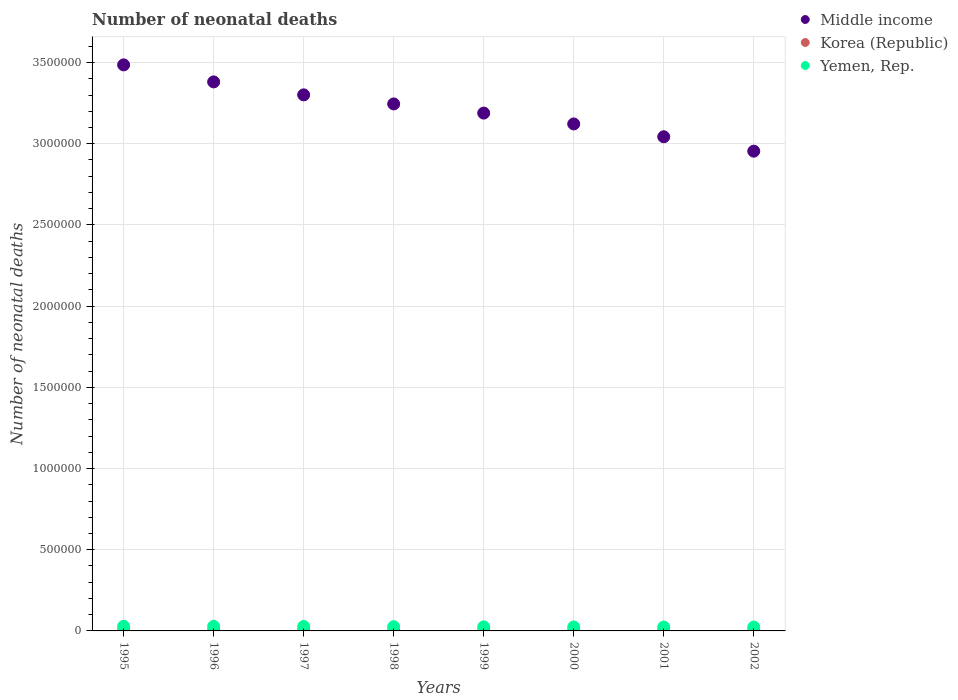How many different coloured dotlines are there?
Keep it short and to the point. 3. Is the number of dotlines equal to the number of legend labels?
Give a very brief answer. Yes. What is the number of neonatal deaths in in Korea (Republic) in 2001?
Your response must be concise. 1320. Across all years, what is the maximum number of neonatal deaths in in Korea (Republic)?
Provide a short and direct response. 1517. Across all years, what is the minimum number of neonatal deaths in in Korea (Republic)?
Your answer should be compact. 1191. In which year was the number of neonatal deaths in in Yemen, Rep. minimum?
Your response must be concise. 2002. What is the total number of neonatal deaths in in Yemen, Rep. in the graph?
Your answer should be very brief. 2.07e+05. What is the difference between the number of neonatal deaths in in Korea (Republic) in 2001 and that in 2002?
Your response must be concise. -79. What is the difference between the number of neonatal deaths in in Yemen, Rep. in 1995 and the number of neonatal deaths in in Middle income in 1996?
Your answer should be compact. -3.35e+06. What is the average number of neonatal deaths in in Yemen, Rep. per year?
Give a very brief answer. 2.59e+04. In the year 1999, what is the difference between the number of neonatal deaths in in Yemen, Rep. and number of neonatal deaths in in Korea (Republic)?
Your answer should be compact. 2.38e+04. In how many years, is the number of neonatal deaths in in Middle income greater than 1400000?
Offer a terse response. 8. What is the ratio of the number of neonatal deaths in in Yemen, Rep. in 1999 to that in 2001?
Your answer should be very brief. 1.05. What is the difference between the highest and the second highest number of neonatal deaths in in Yemen, Rep.?
Give a very brief answer. 426. What is the difference between the highest and the lowest number of neonatal deaths in in Korea (Republic)?
Offer a very short reply. 326. Is the number of neonatal deaths in in Middle income strictly greater than the number of neonatal deaths in in Yemen, Rep. over the years?
Make the answer very short. Yes. Are the values on the major ticks of Y-axis written in scientific E-notation?
Provide a short and direct response. No. Does the graph contain grids?
Offer a terse response. Yes. Where does the legend appear in the graph?
Ensure brevity in your answer.  Top right. How many legend labels are there?
Ensure brevity in your answer.  3. How are the legend labels stacked?
Make the answer very short. Vertical. What is the title of the graph?
Ensure brevity in your answer.  Number of neonatal deaths. Does "New Caledonia" appear as one of the legend labels in the graph?
Your answer should be compact. No. What is the label or title of the Y-axis?
Give a very brief answer. Number of neonatal deaths. What is the Number of neonatal deaths of Middle income in 1995?
Keep it short and to the point. 3.49e+06. What is the Number of neonatal deaths of Korea (Republic) in 1995?
Give a very brief answer. 1517. What is the Number of neonatal deaths in Yemen, Rep. in 1995?
Ensure brevity in your answer.  2.86e+04. What is the Number of neonatal deaths of Middle income in 1996?
Ensure brevity in your answer.  3.38e+06. What is the Number of neonatal deaths in Korea (Republic) in 1996?
Your response must be concise. 1392. What is the Number of neonatal deaths of Yemen, Rep. in 1996?
Make the answer very short. 2.82e+04. What is the Number of neonatal deaths of Middle income in 1997?
Ensure brevity in your answer.  3.30e+06. What is the Number of neonatal deaths in Korea (Republic) in 1997?
Give a very brief answer. 1288. What is the Number of neonatal deaths in Yemen, Rep. in 1997?
Offer a very short reply. 2.73e+04. What is the Number of neonatal deaths of Middle income in 1998?
Ensure brevity in your answer.  3.25e+06. What is the Number of neonatal deaths of Korea (Republic) in 1998?
Offer a very short reply. 1215. What is the Number of neonatal deaths in Yemen, Rep. in 1998?
Your answer should be very brief. 2.60e+04. What is the Number of neonatal deaths of Middle income in 1999?
Offer a very short reply. 3.19e+06. What is the Number of neonatal deaths in Korea (Republic) in 1999?
Ensure brevity in your answer.  1191. What is the Number of neonatal deaths of Yemen, Rep. in 1999?
Give a very brief answer. 2.50e+04. What is the Number of neonatal deaths of Middle income in 2000?
Provide a succinct answer. 3.12e+06. What is the Number of neonatal deaths of Korea (Republic) in 2000?
Your answer should be compact. 1235. What is the Number of neonatal deaths of Yemen, Rep. in 2000?
Offer a terse response. 2.42e+04. What is the Number of neonatal deaths in Middle income in 2001?
Keep it short and to the point. 3.04e+06. What is the Number of neonatal deaths of Korea (Republic) in 2001?
Ensure brevity in your answer.  1320. What is the Number of neonatal deaths of Yemen, Rep. in 2001?
Keep it short and to the point. 2.38e+04. What is the Number of neonatal deaths of Middle income in 2002?
Your answer should be compact. 2.95e+06. What is the Number of neonatal deaths of Korea (Republic) in 2002?
Your answer should be very brief. 1399. What is the Number of neonatal deaths of Yemen, Rep. in 2002?
Offer a terse response. 2.38e+04. Across all years, what is the maximum Number of neonatal deaths in Middle income?
Offer a terse response. 3.49e+06. Across all years, what is the maximum Number of neonatal deaths of Korea (Republic)?
Provide a succinct answer. 1517. Across all years, what is the maximum Number of neonatal deaths in Yemen, Rep.?
Your response must be concise. 2.86e+04. Across all years, what is the minimum Number of neonatal deaths of Middle income?
Give a very brief answer. 2.95e+06. Across all years, what is the minimum Number of neonatal deaths in Korea (Republic)?
Your response must be concise. 1191. Across all years, what is the minimum Number of neonatal deaths in Yemen, Rep.?
Ensure brevity in your answer.  2.38e+04. What is the total Number of neonatal deaths of Middle income in the graph?
Ensure brevity in your answer.  2.57e+07. What is the total Number of neonatal deaths of Korea (Republic) in the graph?
Your response must be concise. 1.06e+04. What is the total Number of neonatal deaths of Yemen, Rep. in the graph?
Make the answer very short. 2.07e+05. What is the difference between the Number of neonatal deaths of Middle income in 1995 and that in 1996?
Your answer should be compact. 1.05e+05. What is the difference between the Number of neonatal deaths in Korea (Republic) in 1995 and that in 1996?
Ensure brevity in your answer.  125. What is the difference between the Number of neonatal deaths of Yemen, Rep. in 1995 and that in 1996?
Provide a short and direct response. 426. What is the difference between the Number of neonatal deaths in Middle income in 1995 and that in 1997?
Keep it short and to the point. 1.85e+05. What is the difference between the Number of neonatal deaths of Korea (Republic) in 1995 and that in 1997?
Your response must be concise. 229. What is the difference between the Number of neonatal deaths of Yemen, Rep. in 1995 and that in 1997?
Give a very brief answer. 1349. What is the difference between the Number of neonatal deaths in Middle income in 1995 and that in 1998?
Provide a succinct answer. 2.40e+05. What is the difference between the Number of neonatal deaths in Korea (Republic) in 1995 and that in 1998?
Provide a short and direct response. 302. What is the difference between the Number of neonatal deaths of Yemen, Rep. in 1995 and that in 1998?
Make the answer very short. 2568. What is the difference between the Number of neonatal deaths in Middle income in 1995 and that in 1999?
Ensure brevity in your answer.  2.97e+05. What is the difference between the Number of neonatal deaths of Korea (Republic) in 1995 and that in 1999?
Provide a short and direct response. 326. What is the difference between the Number of neonatal deaths in Yemen, Rep. in 1995 and that in 1999?
Offer a very short reply. 3661. What is the difference between the Number of neonatal deaths in Middle income in 1995 and that in 2000?
Make the answer very short. 3.64e+05. What is the difference between the Number of neonatal deaths of Korea (Republic) in 1995 and that in 2000?
Offer a terse response. 282. What is the difference between the Number of neonatal deaths in Yemen, Rep. in 1995 and that in 2000?
Your response must be concise. 4464. What is the difference between the Number of neonatal deaths of Middle income in 1995 and that in 2001?
Provide a succinct answer. 4.43e+05. What is the difference between the Number of neonatal deaths of Korea (Republic) in 1995 and that in 2001?
Ensure brevity in your answer.  197. What is the difference between the Number of neonatal deaths of Yemen, Rep. in 1995 and that in 2001?
Provide a short and direct response. 4795. What is the difference between the Number of neonatal deaths in Middle income in 1995 and that in 2002?
Provide a succinct answer. 5.31e+05. What is the difference between the Number of neonatal deaths of Korea (Republic) in 1995 and that in 2002?
Your answer should be compact. 118. What is the difference between the Number of neonatal deaths of Yemen, Rep. in 1995 and that in 2002?
Keep it short and to the point. 4806. What is the difference between the Number of neonatal deaths in Middle income in 1996 and that in 1997?
Offer a very short reply. 7.98e+04. What is the difference between the Number of neonatal deaths of Korea (Republic) in 1996 and that in 1997?
Your response must be concise. 104. What is the difference between the Number of neonatal deaths in Yemen, Rep. in 1996 and that in 1997?
Offer a very short reply. 923. What is the difference between the Number of neonatal deaths of Middle income in 1996 and that in 1998?
Offer a terse response. 1.36e+05. What is the difference between the Number of neonatal deaths in Korea (Republic) in 1996 and that in 1998?
Offer a very short reply. 177. What is the difference between the Number of neonatal deaths in Yemen, Rep. in 1996 and that in 1998?
Offer a very short reply. 2142. What is the difference between the Number of neonatal deaths in Middle income in 1996 and that in 1999?
Your answer should be compact. 1.92e+05. What is the difference between the Number of neonatal deaths in Korea (Republic) in 1996 and that in 1999?
Your response must be concise. 201. What is the difference between the Number of neonatal deaths in Yemen, Rep. in 1996 and that in 1999?
Your answer should be very brief. 3235. What is the difference between the Number of neonatal deaths in Middle income in 1996 and that in 2000?
Ensure brevity in your answer.  2.59e+05. What is the difference between the Number of neonatal deaths in Korea (Republic) in 1996 and that in 2000?
Keep it short and to the point. 157. What is the difference between the Number of neonatal deaths in Yemen, Rep. in 1996 and that in 2000?
Offer a very short reply. 4038. What is the difference between the Number of neonatal deaths of Middle income in 1996 and that in 2001?
Provide a short and direct response. 3.38e+05. What is the difference between the Number of neonatal deaths in Korea (Republic) in 1996 and that in 2001?
Your answer should be very brief. 72. What is the difference between the Number of neonatal deaths in Yemen, Rep. in 1996 and that in 2001?
Ensure brevity in your answer.  4369. What is the difference between the Number of neonatal deaths in Middle income in 1996 and that in 2002?
Give a very brief answer. 4.27e+05. What is the difference between the Number of neonatal deaths of Korea (Republic) in 1996 and that in 2002?
Make the answer very short. -7. What is the difference between the Number of neonatal deaths of Yemen, Rep. in 1996 and that in 2002?
Provide a short and direct response. 4380. What is the difference between the Number of neonatal deaths in Middle income in 1997 and that in 1998?
Offer a terse response. 5.58e+04. What is the difference between the Number of neonatal deaths of Yemen, Rep. in 1997 and that in 1998?
Make the answer very short. 1219. What is the difference between the Number of neonatal deaths in Middle income in 1997 and that in 1999?
Your response must be concise. 1.12e+05. What is the difference between the Number of neonatal deaths in Korea (Republic) in 1997 and that in 1999?
Offer a very short reply. 97. What is the difference between the Number of neonatal deaths in Yemen, Rep. in 1997 and that in 1999?
Ensure brevity in your answer.  2312. What is the difference between the Number of neonatal deaths of Middle income in 1997 and that in 2000?
Your response must be concise. 1.79e+05. What is the difference between the Number of neonatal deaths in Yemen, Rep. in 1997 and that in 2000?
Offer a terse response. 3115. What is the difference between the Number of neonatal deaths of Middle income in 1997 and that in 2001?
Your answer should be very brief. 2.58e+05. What is the difference between the Number of neonatal deaths of Korea (Republic) in 1997 and that in 2001?
Your response must be concise. -32. What is the difference between the Number of neonatal deaths of Yemen, Rep. in 1997 and that in 2001?
Offer a terse response. 3446. What is the difference between the Number of neonatal deaths of Middle income in 1997 and that in 2002?
Keep it short and to the point. 3.47e+05. What is the difference between the Number of neonatal deaths of Korea (Republic) in 1997 and that in 2002?
Offer a very short reply. -111. What is the difference between the Number of neonatal deaths of Yemen, Rep. in 1997 and that in 2002?
Your answer should be compact. 3457. What is the difference between the Number of neonatal deaths of Middle income in 1998 and that in 1999?
Provide a short and direct response. 5.65e+04. What is the difference between the Number of neonatal deaths of Yemen, Rep. in 1998 and that in 1999?
Provide a succinct answer. 1093. What is the difference between the Number of neonatal deaths in Middle income in 1998 and that in 2000?
Your answer should be compact. 1.23e+05. What is the difference between the Number of neonatal deaths in Korea (Republic) in 1998 and that in 2000?
Give a very brief answer. -20. What is the difference between the Number of neonatal deaths in Yemen, Rep. in 1998 and that in 2000?
Keep it short and to the point. 1896. What is the difference between the Number of neonatal deaths in Middle income in 1998 and that in 2001?
Your response must be concise. 2.02e+05. What is the difference between the Number of neonatal deaths of Korea (Republic) in 1998 and that in 2001?
Make the answer very short. -105. What is the difference between the Number of neonatal deaths of Yemen, Rep. in 1998 and that in 2001?
Provide a short and direct response. 2227. What is the difference between the Number of neonatal deaths of Middle income in 1998 and that in 2002?
Ensure brevity in your answer.  2.91e+05. What is the difference between the Number of neonatal deaths in Korea (Republic) in 1998 and that in 2002?
Make the answer very short. -184. What is the difference between the Number of neonatal deaths in Yemen, Rep. in 1998 and that in 2002?
Give a very brief answer. 2238. What is the difference between the Number of neonatal deaths in Middle income in 1999 and that in 2000?
Your answer should be very brief. 6.68e+04. What is the difference between the Number of neonatal deaths in Korea (Republic) in 1999 and that in 2000?
Your answer should be compact. -44. What is the difference between the Number of neonatal deaths of Yemen, Rep. in 1999 and that in 2000?
Ensure brevity in your answer.  803. What is the difference between the Number of neonatal deaths in Middle income in 1999 and that in 2001?
Provide a succinct answer. 1.46e+05. What is the difference between the Number of neonatal deaths in Korea (Republic) in 1999 and that in 2001?
Your answer should be compact. -129. What is the difference between the Number of neonatal deaths of Yemen, Rep. in 1999 and that in 2001?
Keep it short and to the point. 1134. What is the difference between the Number of neonatal deaths of Middle income in 1999 and that in 2002?
Offer a very short reply. 2.35e+05. What is the difference between the Number of neonatal deaths of Korea (Republic) in 1999 and that in 2002?
Ensure brevity in your answer.  -208. What is the difference between the Number of neonatal deaths in Yemen, Rep. in 1999 and that in 2002?
Provide a short and direct response. 1145. What is the difference between the Number of neonatal deaths of Middle income in 2000 and that in 2001?
Your response must be concise. 7.89e+04. What is the difference between the Number of neonatal deaths of Korea (Republic) in 2000 and that in 2001?
Provide a succinct answer. -85. What is the difference between the Number of neonatal deaths of Yemen, Rep. in 2000 and that in 2001?
Your answer should be compact. 331. What is the difference between the Number of neonatal deaths in Middle income in 2000 and that in 2002?
Your answer should be very brief. 1.68e+05. What is the difference between the Number of neonatal deaths of Korea (Republic) in 2000 and that in 2002?
Your response must be concise. -164. What is the difference between the Number of neonatal deaths of Yemen, Rep. in 2000 and that in 2002?
Your answer should be very brief. 342. What is the difference between the Number of neonatal deaths in Middle income in 2001 and that in 2002?
Make the answer very short. 8.88e+04. What is the difference between the Number of neonatal deaths of Korea (Republic) in 2001 and that in 2002?
Give a very brief answer. -79. What is the difference between the Number of neonatal deaths of Yemen, Rep. in 2001 and that in 2002?
Make the answer very short. 11. What is the difference between the Number of neonatal deaths in Middle income in 1995 and the Number of neonatal deaths in Korea (Republic) in 1996?
Offer a very short reply. 3.48e+06. What is the difference between the Number of neonatal deaths of Middle income in 1995 and the Number of neonatal deaths of Yemen, Rep. in 1996?
Offer a terse response. 3.46e+06. What is the difference between the Number of neonatal deaths in Korea (Republic) in 1995 and the Number of neonatal deaths in Yemen, Rep. in 1996?
Your answer should be very brief. -2.67e+04. What is the difference between the Number of neonatal deaths of Middle income in 1995 and the Number of neonatal deaths of Korea (Republic) in 1997?
Make the answer very short. 3.48e+06. What is the difference between the Number of neonatal deaths of Middle income in 1995 and the Number of neonatal deaths of Yemen, Rep. in 1997?
Make the answer very short. 3.46e+06. What is the difference between the Number of neonatal deaths in Korea (Republic) in 1995 and the Number of neonatal deaths in Yemen, Rep. in 1997?
Provide a succinct answer. -2.58e+04. What is the difference between the Number of neonatal deaths of Middle income in 1995 and the Number of neonatal deaths of Korea (Republic) in 1998?
Give a very brief answer. 3.48e+06. What is the difference between the Number of neonatal deaths of Middle income in 1995 and the Number of neonatal deaths of Yemen, Rep. in 1998?
Make the answer very short. 3.46e+06. What is the difference between the Number of neonatal deaths in Korea (Republic) in 1995 and the Number of neonatal deaths in Yemen, Rep. in 1998?
Your answer should be very brief. -2.45e+04. What is the difference between the Number of neonatal deaths of Middle income in 1995 and the Number of neonatal deaths of Korea (Republic) in 1999?
Your response must be concise. 3.48e+06. What is the difference between the Number of neonatal deaths of Middle income in 1995 and the Number of neonatal deaths of Yemen, Rep. in 1999?
Your answer should be very brief. 3.46e+06. What is the difference between the Number of neonatal deaths in Korea (Republic) in 1995 and the Number of neonatal deaths in Yemen, Rep. in 1999?
Provide a short and direct response. -2.34e+04. What is the difference between the Number of neonatal deaths in Middle income in 1995 and the Number of neonatal deaths in Korea (Republic) in 2000?
Ensure brevity in your answer.  3.48e+06. What is the difference between the Number of neonatal deaths in Middle income in 1995 and the Number of neonatal deaths in Yemen, Rep. in 2000?
Your response must be concise. 3.46e+06. What is the difference between the Number of neonatal deaths of Korea (Republic) in 1995 and the Number of neonatal deaths of Yemen, Rep. in 2000?
Provide a succinct answer. -2.26e+04. What is the difference between the Number of neonatal deaths in Middle income in 1995 and the Number of neonatal deaths in Korea (Republic) in 2001?
Offer a very short reply. 3.48e+06. What is the difference between the Number of neonatal deaths of Middle income in 1995 and the Number of neonatal deaths of Yemen, Rep. in 2001?
Your answer should be compact. 3.46e+06. What is the difference between the Number of neonatal deaths in Korea (Republic) in 1995 and the Number of neonatal deaths in Yemen, Rep. in 2001?
Your answer should be compact. -2.23e+04. What is the difference between the Number of neonatal deaths of Middle income in 1995 and the Number of neonatal deaths of Korea (Republic) in 2002?
Offer a terse response. 3.48e+06. What is the difference between the Number of neonatal deaths of Middle income in 1995 and the Number of neonatal deaths of Yemen, Rep. in 2002?
Your answer should be very brief. 3.46e+06. What is the difference between the Number of neonatal deaths of Korea (Republic) in 1995 and the Number of neonatal deaths of Yemen, Rep. in 2002?
Your response must be concise. -2.23e+04. What is the difference between the Number of neonatal deaths of Middle income in 1996 and the Number of neonatal deaths of Korea (Republic) in 1997?
Ensure brevity in your answer.  3.38e+06. What is the difference between the Number of neonatal deaths in Middle income in 1996 and the Number of neonatal deaths in Yemen, Rep. in 1997?
Ensure brevity in your answer.  3.35e+06. What is the difference between the Number of neonatal deaths in Korea (Republic) in 1996 and the Number of neonatal deaths in Yemen, Rep. in 1997?
Your response must be concise. -2.59e+04. What is the difference between the Number of neonatal deaths in Middle income in 1996 and the Number of neonatal deaths in Korea (Republic) in 1998?
Your answer should be very brief. 3.38e+06. What is the difference between the Number of neonatal deaths in Middle income in 1996 and the Number of neonatal deaths in Yemen, Rep. in 1998?
Provide a short and direct response. 3.35e+06. What is the difference between the Number of neonatal deaths of Korea (Republic) in 1996 and the Number of neonatal deaths of Yemen, Rep. in 1998?
Your answer should be very brief. -2.47e+04. What is the difference between the Number of neonatal deaths in Middle income in 1996 and the Number of neonatal deaths in Korea (Republic) in 1999?
Your answer should be very brief. 3.38e+06. What is the difference between the Number of neonatal deaths of Middle income in 1996 and the Number of neonatal deaths of Yemen, Rep. in 1999?
Offer a terse response. 3.36e+06. What is the difference between the Number of neonatal deaths of Korea (Republic) in 1996 and the Number of neonatal deaths of Yemen, Rep. in 1999?
Your answer should be compact. -2.36e+04. What is the difference between the Number of neonatal deaths in Middle income in 1996 and the Number of neonatal deaths in Korea (Republic) in 2000?
Ensure brevity in your answer.  3.38e+06. What is the difference between the Number of neonatal deaths in Middle income in 1996 and the Number of neonatal deaths in Yemen, Rep. in 2000?
Provide a succinct answer. 3.36e+06. What is the difference between the Number of neonatal deaths in Korea (Republic) in 1996 and the Number of neonatal deaths in Yemen, Rep. in 2000?
Your answer should be very brief. -2.28e+04. What is the difference between the Number of neonatal deaths of Middle income in 1996 and the Number of neonatal deaths of Korea (Republic) in 2001?
Keep it short and to the point. 3.38e+06. What is the difference between the Number of neonatal deaths of Middle income in 1996 and the Number of neonatal deaths of Yemen, Rep. in 2001?
Offer a terse response. 3.36e+06. What is the difference between the Number of neonatal deaths of Korea (Republic) in 1996 and the Number of neonatal deaths of Yemen, Rep. in 2001?
Your response must be concise. -2.24e+04. What is the difference between the Number of neonatal deaths in Middle income in 1996 and the Number of neonatal deaths in Korea (Republic) in 2002?
Make the answer very short. 3.38e+06. What is the difference between the Number of neonatal deaths in Middle income in 1996 and the Number of neonatal deaths in Yemen, Rep. in 2002?
Make the answer very short. 3.36e+06. What is the difference between the Number of neonatal deaths in Korea (Republic) in 1996 and the Number of neonatal deaths in Yemen, Rep. in 2002?
Give a very brief answer. -2.24e+04. What is the difference between the Number of neonatal deaths of Middle income in 1997 and the Number of neonatal deaths of Korea (Republic) in 1998?
Ensure brevity in your answer.  3.30e+06. What is the difference between the Number of neonatal deaths in Middle income in 1997 and the Number of neonatal deaths in Yemen, Rep. in 1998?
Provide a succinct answer. 3.27e+06. What is the difference between the Number of neonatal deaths of Korea (Republic) in 1997 and the Number of neonatal deaths of Yemen, Rep. in 1998?
Offer a terse response. -2.48e+04. What is the difference between the Number of neonatal deaths of Middle income in 1997 and the Number of neonatal deaths of Korea (Republic) in 1999?
Offer a very short reply. 3.30e+06. What is the difference between the Number of neonatal deaths of Middle income in 1997 and the Number of neonatal deaths of Yemen, Rep. in 1999?
Offer a very short reply. 3.28e+06. What is the difference between the Number of neonatal deaths of Korea (Republic) in 1997 and the Number of neonatal deaths of Yemen, Rep. in 1999?
Offer a very short reply. -2.37e+04. What is the difference between the Number of neonatal deaths of Middle income in 1997 and the Number of neonatal deaths of Korea (Republic) in 2000?
Offer a very short reply. 3.30e+06. What is the difference between the Number of neonatal deaths in Middle income in 1997 and the Number of neonatal deaths in Yemen, Rep. in 2000?
Make the answer very short. 3.28e+06. What is the difference between the Number of neonatal deaths of Korea (Republic) in 1997 and the Number of neonatal deaths of Yemen, Rep. in 2000?
Provide a succinct answer. -2.29e+04. What is the difference between the Number of neonatal deaths in Middle income in 1997 and the Number of neonatal deaths in Korea (Republic) in 2001?
Your answer should be very brief. 3.30e+06. What is the difference between the Number of neonatal deaths of Middle income in 1997 and the Number of neonatal deaths of Yemen, Rep. in 2001?
Keep it short and to the point. 3.28e+06. What is the difference between the Number of neonatal deaths of Korea (Republic) in 1997 and the Number of neonatal deaths of Yemen, Rep. in 2001?
Offer a terse response. -2.25e+04. What is the difference between the Number of neonatal deaths in Middle income in 1997 and the Number of neonatal deaths in Korea (Republic) in 2002?
Your answer should be very brief. 3.30e+06. What is the difference between the Number of neonatal deaths in Middle income in 1997 and the Number of neonatal deaths in Yemen, Rep. in 2002?
Give a very brief answer. 3.28e+06. What is the difference between the Number of neonatal deaths in Korea (Republic) in 1997 and the Number of neonatal deaths in Yemen, Rep. in 2002?
Provide a short and direct response. -2.25e+04. What is the difference between the Number of neonatal deaths in Middle income in 1998 and the Number of neonatal deaths in Korea (Republic) in 1999?
Provide a short and direct response. 3.24e+06. What is the difference between the Number of neonatal deaths in Middle income in 1998 and the Number of neonatal deaths in Yemen, Rep. in 1999?
Offer a terse response. 3.22e+06. What is the difference between the Number of neonatal deaths of Korea (Republic) in 1998 and the Number of neonatal deaths of Yemen, Rep. in 1999?
Your response must be concise. -2.37e+04. What is the difference between the Number of neonatal deaths of Middle income in 1998 and the Number of neonatal deaths of Korea (Republic) in 2000?
Offer a terse response. 3.24e+06. What is the difference between the Number of neonatal deaths in Middle income in 1998 and the Number of neonatal deaths in Yemen, Rep. in 2000?
Keep it short and to the point. 3.22e+06. What is the difference between the Number of neonatal deaths of Korea (Republic) in 1998 and the Number of neonatal deaths of Yemen, Rep. in 2000?
Give a very brief answer. -2.29e+04. What is the difference between the Number of neonatal deaths of Middle income in 1998 and the Number of neonatal deaths of Korea (Republic) in 2001?
Your answer should be compact. 3.24e+06. What is the difference between the Number of neonatal deaths of Middle income in 1998 and the Number of neonatal deaths of Yemen, Rep. in 2001?
Offer a terse response. 3.22e+06. What is the difference between the Number of neonatal deaths of Korea (Republic) in 1998 and the Number of neonatal deaths of Yemen, Rep. in 2001?
Your response must be concise. -2.26e+04. What is the difference between the Number of neonatal deaths in Middle income in 1998 and the Number of neonatal deaths in Korea (Republic) in 2002?
Your answer should be very brief. 3.24e+06. What is the difference between the Number of neonatal deaths of Middle income in 1998 and the Number of neonatal deaths of Yemen, Rep. in 2002?
Offer a terse response. 3.22e+06. What is the difference between the Number of neonatal deaths in Korea (Republic) in 1998 and the Number of neonatal deaths in Yemen, Rep. in 2002?
Make the answer very short. -2.26e+04. What is the difference between the Number of neonatal deaths in Middle income in 1999 and the Number of neonatal deaths in Korea (Republic) in 2000?
Ensure brevity in your answer.  3.19e+06. What is the difference between the Number of neonatal deaths of Middle income in 1999 and the Number of neonatal deaths of Yemen, Rep. in 2000?
Your answer should be compact. 3.16e+06. What is the difference between the Number of neonatal deaths in Korea (Republic) in 1999 and the Number of neonatal deaths in Yemen, Rep. in 2000?
Your answer should be compact. -2.30e+04. What is the difference between the Number of neonatal deaths in Middle income in 1999 and the Number of neonatal deaths in Korea (Republic) in 2001?
Keep it short and to the point. 3.19e+06. What is the difference between the Number of neonatal deaths of Middle income in 1999 and the Number of neonatal deaths of Yemen, Rep. in 2001?
Your answer should be very brief. 3.16e+06. What is the difference between the Number of neonatal deaths of Korea (Republic) in 1999 and the Number of neonatal deaths of Yemen, Rep. in 2001?
Offer a very short reply. -2.26e+04. What is the difference between the Number of neonatal deaths of Middle income in 1999 and the Number of neonatal deaths of Korea (Republic) in 2002?
Your response must be concise. 3.19e+06. What is the difference between the Number of neonatal deaths of Middle income in 1999 and the Number of neonatal deaths of Yemen, Rep. in 2002?
Offer a terse response. 3.16e+06. What is the difference between the Number of neonatal deaths of Korea (Republic) in 1999 and the Number of neonatal deaths of Yemen, Rep. in 2002?
Offer a very short reply. -2.26e+04. What is the difference between the Number of neonatal deaths in Middle income in 2000 and the Number of neonatal deaths in Korea (Republic) in 2001?
Ensure brevity in your answer.  3.12e+06. What is the difference between the Number of neonatal deaths of Middle income in 2000 and the Number of neonatal deaths of Yemen, Rep. in 2001?
Ensure brevity in your answer.  3.10e+06. What is the difference between the Number of neonatal deaths of Korea (Republic) in 2000 and the Number of neonatal deaths of Yemen, Rep. in 2001?
Keep it short and to the point. -2.26e+04. What is the difference between the Number of neonatal deaths in Middle income in 2000 and the Number of neonatal deaths in Korea (Republic) in 2002?
Offer a terse response. 3.12e+06. What is the difference between the Number of neonatal deaths in Middle income in 2000 and the Number of neonatal deaths in Yemen, Rep. in 2002?
Ensure brevity in your answer.  3.10e+06. What is the difference between the Number of neonatal deaths in Korea (Republic) in 2000 and the Number of neonatal deaths in Yemen, Rep. in 2002?
Offer a very short reply. -2.26e+04. What is the difference between the Number of neonatal deaths of Middle income in 2001 and the Number of neonatal deaths of Korea (Republic) in 2002?
Your answer should be compact. 3.04e+06. What is the difference between the Number of neonatal deaths in Middle income in 2001 and the Number of neonatal deaths in Yemen, Rep. in 2002?
Offer a very short reply. 3.02e+06. What is the difference between the Number of neonatal deaths in Korea (Republic) in 2001 and the Number of neonatal deaths in Yemen, Rep. in 2002?
Provide a short and direct response. -2.25e+04. What is the average Number of neonatal deaths in Middle income per year?
Your answer should be very brief. 3.22e+06. What is the average Number of neonatal deaths of Korea (Republic) per year?
Offer a very short reply. 1319.62. What is the average Number of neonatal deaths in Yemen, Rep. per year?
Provide a short and direct response. 2.59e+04. In the year 1995, what is the difference between the Number of neonatal deaths of Middle income and Number of neonatal deaths of Korea (Republic)?
Offer a very short reply. 3.48e+06. In the year 1995, what is the difference between the Number of neonatal deaths of Middle income and Number of neonatal deaths of Yemen, Rep.?
Your response must be concise. 3.46e+06. In the year 1995, what is the difference between the Number of neonatal deaths of Korea (Republic) and Number of neonatal deaths of Yemen, Rep.?
Give a very brief answer. -2.71e+04. In the year 1996, what is the difference between the Number of neonatal deaths of Middle income and Number of neonatal deaths of Korea (Republic)?
Your response must be concise. 3.38e+06. In the year 1996, what is the difference between the Number of neonatal deaths of Middle income and Number of neonatal deaths of Yemen, Rep.?
Your response must be concise. 3.35e+06. In the year 1996, what is the difference between the Number of neonatal deaths of Korea (Republic) and Number of neonatal deaths of Yemen, Rep.?
Give a very brief answer. -2.68e+04. In the year 1997, what is the difference between the Number of neonatal deaths in Middle income and Number of neonatal deaths in Korea (Republic)?
Provide a short and direct response. 3.30e+06. In the year 1997, what is the difference between the Number of neonatal deaths of Middle income and Number of neonatal deaths of Yemen, Rep.?
Your answer should be very brief. 3.27e+06. In the year 1997, what is the difference between the Number of neonatal deaths in Korea (Republic) and Number of neonatal deaths in Yemen, Rep.?
Your answer should be compact. -2.60e+04. In the year 1998, what is the difference between the Number of neonatal deaths of Middle income and Number of neonatal deaths of Korea (Republic)?
Offer a very short reply. 3.24e+06. In the year 1998, what is the difference between the Number of neonatal deaths in Middle income and Number of neonatal deaths in Yemen, Rep.?
Ensure brevity in your answer.  3.22e+06. In the year 1998, what is the difference between the Number of neonatal deaths of Korea (Republic) and Number of neonatal deaths of Yemen, Rep.?
Provide a succinct answer. -2.48e+04. In the year 1999, what is the difference between the Number of neonatal deaths in Middle income and Number of neonatal deaths in Korea (Republic)?
Your response must be concise. 3.19e+06. In the year 1999, what is the difference between the Number of neonatal deaths of Middle income and Number of neonatal deaths of Yemen, Rep.?
Make the answer very short. 3.16e+06. In the year 1999, what is the difference between the Number of neonatal deaths of Korea (Republic) and Number of neonatal deaths of Yemen, Rep.?
Your answer should be compact. -2.38e+04. In the year 2000, what is the difference between the Number of neonatal deaths in Middle income and Number of neonatal deaths in Korea (Republic)?
Your answer should be very brief. 3.12e+06. In the year 2000, what is the difference between the Number of neonatal deaths of Middle income and Number of neonatal deaths of Yemen, Rep.?
Your answer should be very brief. 3.10e+06. In the year 2000, what is the difference between the Number of neonatal deaths in Korea (Republic) and Number of neonatal deaths in Yemen, Rep.?
Your answer should be very brief. -2.29e+04. In the year 2001, what is the difference between the Number of neonatal deaths in Middle income and Number of neonatal deaths in Korea (Republic)?
Your answer should be compact. 3.04e+06. In the year 2001, what is the difference between the Number of neonatal deaths in Middle income and Number of neonatal deaths in Yemen, Rep.?
Make the answer very short. 3.02e+06. In the year 2001, what is the difference between the Number of neonatal deaths in Korea (Republic) and Number of neonatal deaths in Yemen, Rep.?
Make the answer very short. -2.25e+04. In the year 2002, what is the difference between the Number of neonatal deaths in Middle income and Number of neonatal deaths in Korea (Republic)?
Keep it short and to the point. 2.95e+06. In the year 2002, what is the difference between the Number of neonatal deaths of Middle income and Number of neonatal deaths of Yemen, Rep.?
Your answer should be very brief. 2.93e+06. In the year 2002, what is the difference between the Number of neonatal deaths in Korea (Republic) and Number of neonatal deaths in Yemen, Rep.?
Provide a succinct answer. -2.24e+04. What is the ratio of the Number of neonatal deaths in Middle income in 1995 to that in 1996?
Your answer should be compact. 1.03. What is the ratio of the Number of neonatal deaths in Korea (Republic) in 1995 to that in 1996?
Offer a terse response. 1.09. What is the ratio of the Number of neonatal deaths in Yemen, Rep. in 1995 to that in 1996?
Your answer should be compact. 1.02. What is the ratio of the Number of neonatal deaths in Middle income in 1995 to that in 1997?
Ensure brevity in your answer.  1.06. What is the ratio of the Number of neonatal deaths in Korea (Republic) in 1995 to that in 1997?
Give a very brief answer. 1.18. What is the ratio of the Number of neonatal deaths in Yemen, Rep. in 1995 to that in 1997?
Ensure brevity in your answer.  1.05. What is the ratio of the Number of neonatal deaths of Middle income in 1995 to that in 1998?
Provide a succinct answer. 1.07. What is the ratio of the Number of neonatal deaths of Korea (Republic) in 1995 to that in 1998?
Ensure brevity in your answer.  1.25. What is the ratio of the Number of neonatal deaths in Yemen, Rep. in 1995 to that in 1998?
Provide a succinct answer. 1.1. What is the ratio of the Number of neonatal deaths in Middle income in 1995 to that in 1999?
Your answer should be very brief. 1.09. What is the ratio of the Number of neonatal deaths in Korea (Republic) in 1995 to that in 1999?
Your response must be concise. 1.27. What is the ratio of the Number of neonatal deaths of Yemen, Rep. in 1995 to that in 1999?
Offer a terse response. 1.15. What is the ratio of the Number of neonatal deaths of Middle income in 1995 to that in 2000?
Keep it short and to the point. 1.12. What is the ratio of the Number of neonatal deaths in Korea (Republic) in 1995 to that in 2000?
Provide a succinct answer. 1.23. What is the ratio of the Number of neonatal deaths of Yemen, Rep. in 1995 to that in 2000?
Your answer should be very brief. 1.18. What is the ratio of the Number of neonatal deaths in Middle income in 1995 to that in 2001?
Make the answer very short. 1.15. What is the ratio of the Number of neonatal deaths of Korea (Republic) in 1995 to that in 2001?
Your response must be concise. 1.15. What is the ratio of the Number of neonatal deaths of Yemen, Rep. in 1995 to that in 2001?
Keep it short and to the point. 1.2. What is the ratio of the Number of neonatal deaths in Middle income in 1995 to that in 2002?
Provide a succinct answer. 1.18. What is the ratio of the Number of neonatal deaths of Korea (Republic) in 1995 to that in 2002?
Provide a succinct answer. 1.08. What is the ratio of the Number of neonatal deaths of Yemen, Rep. in 1995 to that in 2002?
Ensure brevity in your answer.  1.2. What is the ratio of the Number of neonatal deaths of Middle income in 1996 to that in 1997?
Keep it short and to the point. 1.02. What is the ratio of the Number of neonatal deaths in Korea (Republic) in 1996 to that in 1997?
Offer a terse response. 1.08. What is the ratio of the Number of neonatal deaths in Yemen, Rep. in 1996 to that in 1997?
Provide a succinct answer. 1.03. What is the ratio of the Number of neonatal deaths in Middle income in 1996 to that in 1998?
Offer a very short reply. 1.04. What is the ratio of the Number of neonatal deaths in Korea (Republic) in 1996 to that in 1998?
Make the answer very short. 1.15. What is the ratio of the Number of neonatal deaths of Yemen, Rep. in 1996 to that in 1998?
Keep it short and to the point. 1.08. What is the ratio of the Number of neonatal deaths in Middle income in 1996 to that in 1999?
Keep it short and to the point. 1.06. What is the ratio of the Number of neonatal deaths in Korea (Republic) in 1996 to that in 1999?
Provide a succinct answer. 1.17. What is the ratio of the Number of neonatal deaths of Yemen, Rep. in 1996 to that in 1999?
Your answer should be very brief. 1.13. What is the ratio of the Number of neonatal deaths of Middle income in 1996 to that in 2000?
Make the answer very short. 1.08. What is the ratio of the Number of neonatal deaths of Korea (Republic) in 1996 to that in 2000?
Make the answer very short. 1.13. What is the ratio of the Number of neonatal deaths in Yemen, Rep. in 1996 to that in 2000?
Offer a very short reply. 1.17. What is the ratio of the Number of neonatal deaths in Middle income in 1996 to that in 2001?
Provide a succinct answer. 1.11. What is the ratio of the Number of neonatal deaths of Korea (Republic) in 1996 to that in 2001?
Ensure brevity in your answer.  1.05. What is the ratio of the Number of neonatal deaths of Yemen, Rep. in 1996 to that in 2001?
Provide a succinct answer. 1.18. What is the ratio of the Number of neonatal deaths in Middle income in 1996 to that in 2002?
Give a very brief answer. 1.14. What is the ratio of the Number of neonatal deaths of Korea (Republic) in 1996 to that in 2002?
Your response must be concise. 0.99. What is the ratio of the Number of neonatal deaths of Yemen, Rep. in 1996 to that in 2002?
Your response must be concise. 1.18. What is the ratio of the Number of neonatal deaths of Middle income in 1997 to that in 1998?
Your answer should be very brief. 1.02. What is the ratio of the Number of neonatal deaths in Korea (Republic) in 1997 to that in 1998?
Offer a terse response. 1.06. What is the ratio of the Number of neonatal deaths of Yemen, Rep. in 1997 to that in 1998?
Keep it short and to the point. 1.05. What is the ratio of the Number of neonatal deaths of Middle income in 1997 to that in 1999?
Offer a very short reply. 1.04. What is the ratio of the Number of neonatal deaths in Korea (Republic) in 1997 to that in 1999?
Give a very brief answer. 1.08. What is the ratio of the Number of neonatal deaths in Yemen, Rep. in 1997 to that in 1999?
Provide a short and direct response. 1.09. What is the ratio of the Number of neonatal deaths in Middle income in 1997 to that in 2000?
Ensure brevity in your answer.  1.06. What is the ratio of the Number of neonatal deaths in Korea (Republic) in 1997 to that in 2000?
Your response must be concise. 1.04. What is the ratio of the Number of neonatal deaths in Yemen, Rep. in 1997 to that in 2000?
Keep it short and to the point. 1.13. What is the ratio of the Number of neonatal deaths of Middle income in 1997 to that in 2001?
Keep it short and to the point. 1.08. What is the ratio of the Number of neonatal deaths in Korea (Republic) in 1997 to that in 2001?
Your answer should be compact. 0.98. What is the ratio of the Number of neonatal deaths in Yemen, Rep. in 1997 to that in 2001?
Offer a terse response. 1.14. What is the ratio of the Number of neonatal deaths in Middle income in 1997 to that in 2002?
Give a very brief answer. 1.12. What is the ratio of the Number of neonatal deaths of Korea (Republic) in 1997 to that in 2002?
Offer a very short reply. 0.92. What is the ratio of the Number of neonatal deaths of Yemen, Rep. in 1997 to that in 2002?
Your answer should be very brief. 1.15. What is the ratio of the Number of neonatal deaths of Middle income in 1998 to that in 1999?
Keep it short and to the point. 1.02. What is the ratio of the Number of neonatal deaths in Korea (Republic) in 1998 to that in 1999?
Give a very brief answer. 1.02. What is the ratio of the Number of neonatal deaths of Yemen, Rep. in 1998 to that in 1999?
Make the answer very short. 1.04. What is the ratio of the Number of neonatal deaths of Middle income in 1998 to that in 2000?
Your answer should be compact. 1.04. What is the ratio of the Number of neonatal deaths of Korea (Republic) in 1998 to that in 2000?
Your response must be concise. 0.98. What is the ratio of the Number of neonatal deaths of Yemen, Rep. in 1998 to that in 2000?
Give a very brief answer. 1.08. What is the ratio of the Number of neonatal deaths of Middle income in 1998 to that in 2001?
Your answer should be compact. 1.07. What is the ratio of the Number of neonatal deaths in Korea (Republic) in 1998 to that in 2001?
Provide a short and direct response. 0.92. What is the ratio of the Number of neonatal deaths in Yemen, Rep. in 1998 to that in 2001?
Offer a terse response. 1.09. What is the ratio of the Number of neonatal deaths in Middle income in 1998 to that in 2002?
Make the answer very short. 1.1. What is the ratio of the Number of neonatal deaths in Korea (Republic) in 1998 to that in 2002?
Your answer should be very brief. 0.87. What is the ratio of the Number of neonatal deaths of Yemen, Rep. in 1998 to that in 2002?
Your response must be concise. 1.09. What is the ratio of the Number of neonatal deaths in Middle income in 1999 to that in 2000?
Give a very brief answer. 1.02. What is the ratio of the Number of neonatal deaths in Korea (Republic) in 1999 to that in 2000?
Make the answer very short. 0.96. What is the ratio of the Number of neonatal deaths in Yemen, Rep. in 1999 to that in 2000?
Give a very brief answer. 1.03. What is the ratio of the Number of neonatal deaths of Middle income in 1999 to that in 2001?
Provide a short and direct response. 1.05. What is the ratio of the Number of neonatal deaths of Korea (Republic) in 1999 to that in 2001?
Your response must be concise. 0.9. What is the ratio of the Number of neonatal deaths of Yemen, Rep. in 1999 to that in 2001?
Offer a terse response. 1.05. What is the ratio of the Number of neonatal deaths of Middle income in 1999 to that in 2002?
Keep it short and to the point. 1.08. What is the ratio of the Number of neonatal deaths in Korea (Republic) in 1999 to that in 2002?
Offer a terse response. 0.85. What is the ratio of the Number of neonatal deaths in Yemen, Rep. in 1999 to that in 2002?
Provide a short and direct response. 1.05. What is the ratio of the Number of neonatal deaths of Middle income in 2000 to that in 2001?
Provide a succinct answer. 1.03. What is the ratio of the Number of neonatal deaths in Korea (Republic) in 2000 to that in 2001?
Make the answer very short. 0.94. What is the ratio of the Number of neonatal deaths of Yemen, Rep. in 2000 to that in 2001?
Offer a terse response. 1.01. What is the ratio of the Number of neonatal deaths of Middle income in 2000 to that in 2002?
Offer a terse response. 1.06. What is the ratio of the Number of neonatal deaths in Korea (Republic) in 2000 to that in 2002?
Your answer should be very brief. 0.88. What is the ratio of the Number of neonatal deaths of Yemen, Rep. in 2000 to that in 2002?
Offer a terse response. 1.01. What is the ratio of the Number of neonatal deaths in Middle income in 2001 to that in 2002?
Make the answer very short. 1.03. What is the ratio of the Number of neonatal deaths of Korea (Republic) in 2001 to that in 2002?
Ensure brevity in your answer.  0.94. What is the ratio of the Number of neonatal deaths in Yemen, Rep. in 2001 to that in 2002?
Offer a very short reply. 1. What is the difference between the highest and the second highest Number of neonatal deaths in Middle income?
Give a very brief answer. 1.05e+05. What is the difference between the highest and the second highest Number of neonatal deaths in Korea (Republic)?
Offer a very short reply. 118. What is the difference between the highest and the second highest Number of neonatal deaths of Yemen, Rep.?
Ensure brevity in your answer.  426. What is the difference between the highest and the lowest Number of neonatal deaths of Middle income?
Offer a very short reply. 5.31e+05. What is the difference between the highest and the lowest Number of neonatal deaths of Korea (Republic)?
Your answer should be compact. 326. What is the difference between the highest and the lowest Number of neonatal deaths in Yemen, Rep.?
Provide a succinct answer. 4806. 